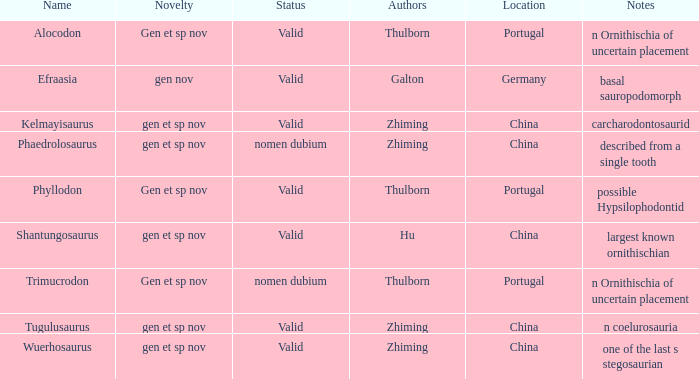What are the Notes of the dinosaur, whose Status is nomen dubium, and whose Location is China? Described from a single tooth. 